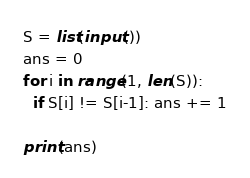<code> <loc_0><loc_0><loc_500><loc_500><_Python_>S = list(input())
ans = 0
for i in range(1, len(S)):
  if S[i] != S[i-1]: ans += 1
    
print(ans)</code> 